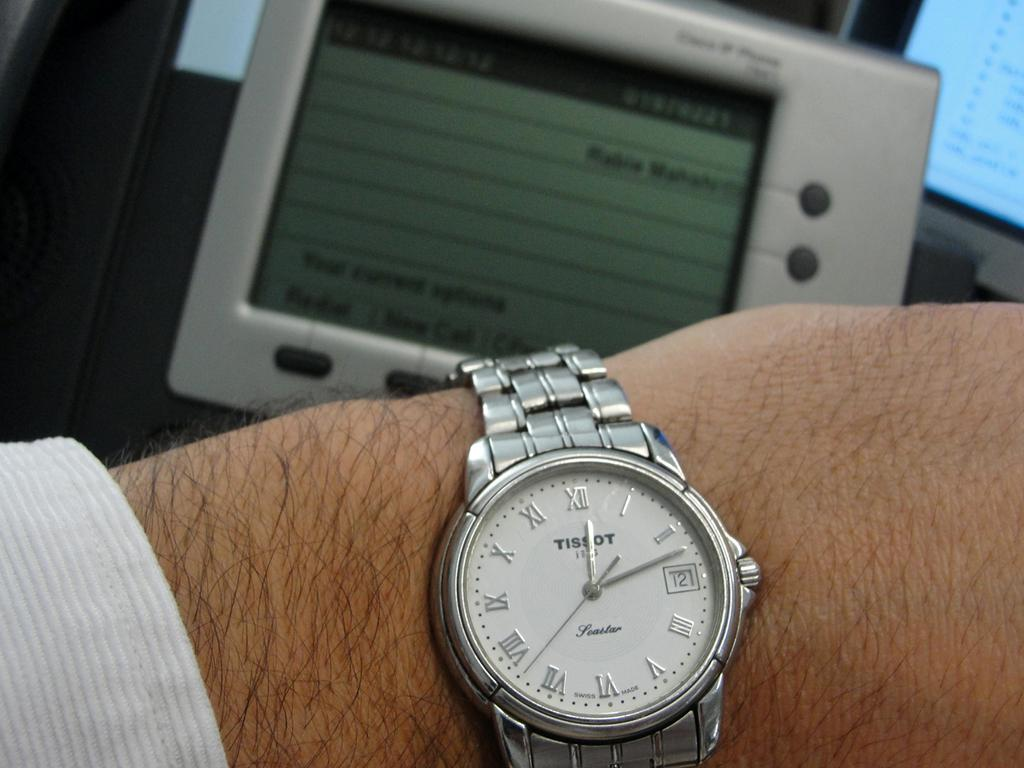<image>
Share a concise interpretation of the image provided. Person wearing a silver watch that says TISSOT on it. 